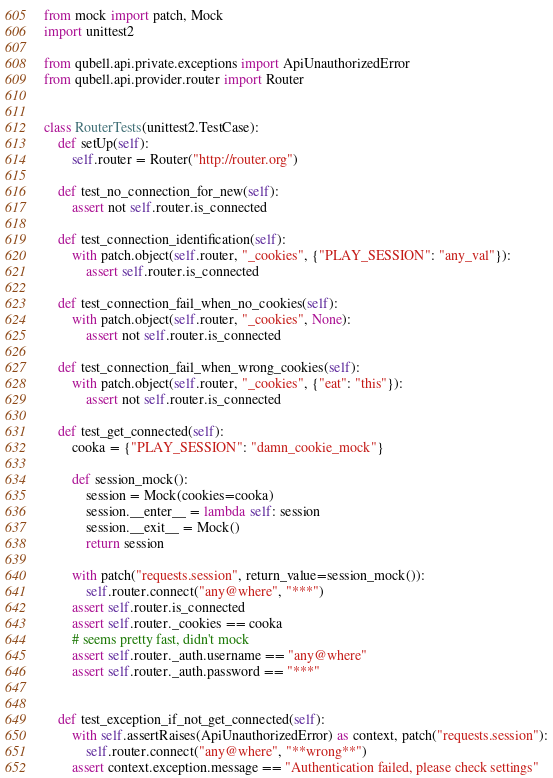<code> <loc_0><loc_0><loc_500><loc_500><_Python_>from mock import patch, Mock
import unittest2

from qubell.api.private.exceptions import ApiUnauthorizedError
from qubell.api.provider.router import Router


class RouterTests(unittest2.TestCase):
    def setUp(self):
        self.router = Router("http://router.org")

    def test_no_connection_for_new(self):
        assert not self.router.is_connected

    def test_connection_identification(self):
        with patch.object(self.router, "_cookies", {"PLAY_SESSION": "any_val"}):
            assert self.router.is_connected

    def test_connection_fail_when_no_cookies(self):
        with patch.object(self.router, "_cookies", None):
            assert not self.router.is_connected

    def test_connection_fail_when_wrong_cookies(self):
        with patch.object(self.router, "_cookies", {"eat": "this"}):
            assert not self.router.is_connected

    def test_get_connected(self):
        cooka = {"PLAY_SESSION": "damn_cookie_mock"}

        def session_mock():
            session = Mock(cookies=cooka)
            session.__enter__ = lambda self: session
            session.__exit__ = Mock()
            return session

        with patch("requests.session", return_value=session_mock()):
            self.router.connect("any@where", "***")
        assert self.router.is_connected
        assert self.router._cookies == cooka
        # seems pretty fast, didn't mock
        assert self.router._auth.username == "any@where"
        assert self.router._auth.password == "***"


    def test_exception_if_not_get_connected(self):
        with self.assertRaises(ApiUnauthorizedError) as context, patch("requests.session"):
            self.router.connect("any@where", "**wrong**")
        assert context.exception.message == "Authentication failed, please check settings"

</code> 